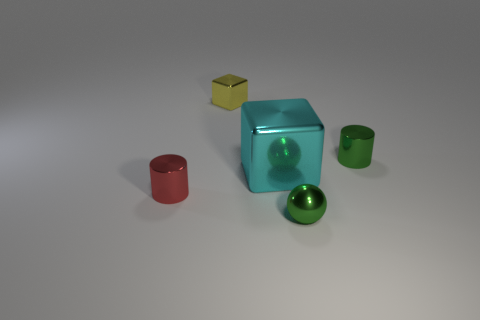Add 1 tiny brown matte cubes. How many objects exist? 6 Subtract all cylinders. How many objects are left? 3 Subtract 0 brown cubes. How many objects are left? 5 Subtract all yellow blocks. Subtract all green metal cylinders. How many objects are left? 3 Add 2 small green objects. How many small green objects are left? 4 Add 5 yellow metallic things. How many yellow metallic things exist? 6 